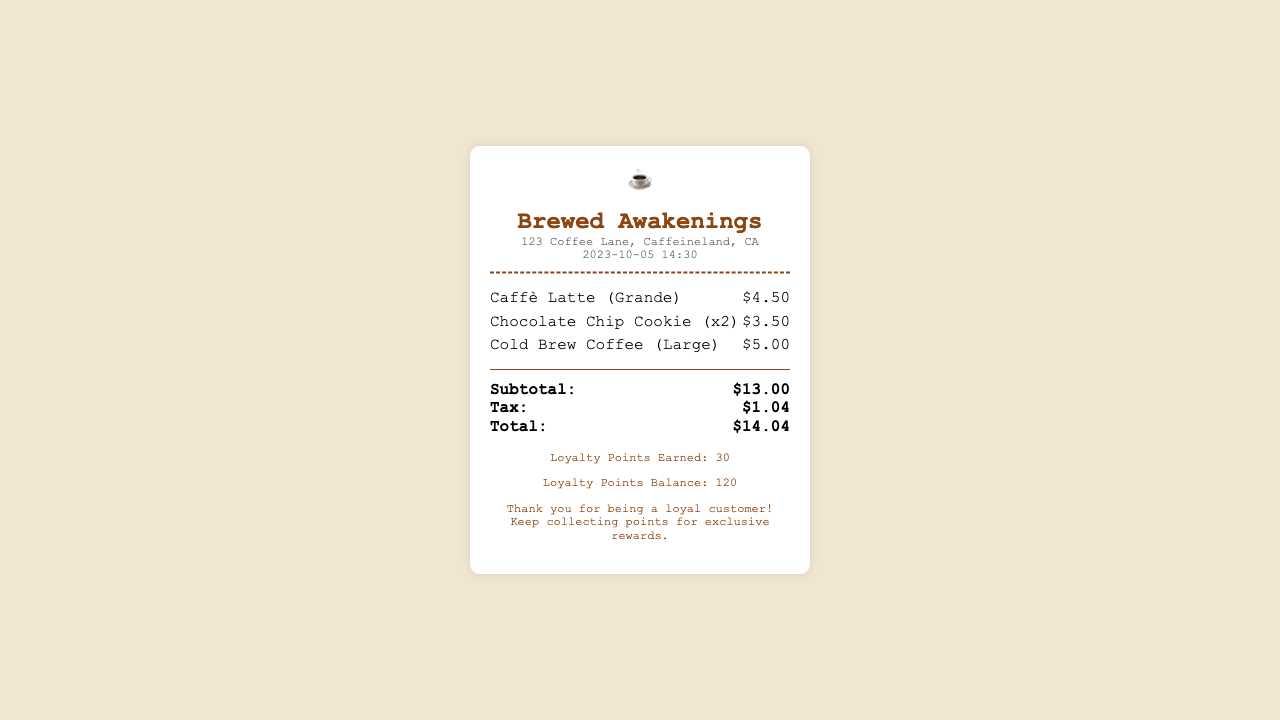What is the name of the coffee shop? The name of the coffee shop is prominently displayed at the top of the document.
Answer: Brewed Awakenings What date was the purchase made? The date is shown in the date-time section of the receipt.
Answer: 2023-10-05 How much was the Caffè Latte? The price of the Caffè Latte can be found in the items section of the receipt.
Answer: $4.50 What is the subtotal of the order? The subtotal is calculated before tax and is listed in the totals section of the receipt.
Answer: $13.00 How many loyalty points were earned? The loyalty points earned is stated in the loyalty section of the receipt.
Answer: 30 What is the total price including tax? The total reflects the entire amount due after tax, found in the totals section.
Answer: $14.04 How many chocolate chip cookies were ordered? The quantity of cookies is specified in the item details on the receipt.
Answer: x2 What is the loyalty points balance? The loyalty points balance can be found in the loyalty section of the receipt.
Answer: 120 What is the location of the coffee shop? The location is displayed below the shop name on the receipt.
Answer: 123 Coffee Lane, Caffeineland, CA 